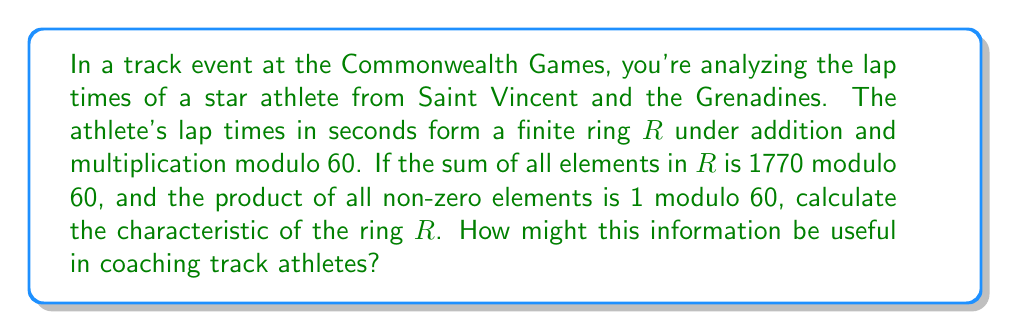Show me your answer to this math problem. Let's approach this step-by-step:

1) In a finite ring, the characteristic is the smallest positive integer $n$ such that $n \cdot a = 0$ for all elements $a$ in the ring. In this case, we're working modulo 60, so the characteristic must be a divisor of 60.

2) The sum of all elements in $R$ is 1770 mod 60, which is equivalent to 30 mod 60. Let's call the number of elements in $R$ as $|R|$. Then:

   $\sum_{a \in R} a \equiv 30 \pmod{60}$

3) The product of all non-zero elements is 1 mod 60. This is a key piece of information, as it's only possible in a field. The only field structure possible modulo 60 is $\mathbb{Z}_5$, as 5 is the only prime factor of 60 that works here.

4) So, $R$ must be isomorphic to $\mathbb{Z}_5$, and $|R| = 5$.

5) Now, let's use the sum information:

   $\sum_{a \in R} a \equiv 0 + 1 + 2 + 3 + 4 \equiv 10 \equiv 30 \pmod{60}$

6) This confirms our deduction that $R$ is isomorphic to $\mathbb{Z}_5$.

7) The characteristic of $\mathbb{Z}_5$ is 5.

As a coach, this information could be useful in several ways:
- The characteristic 5 suggests the athlete's lap times fall into 5 distinct categories modulo 60, which could help in identifying patterns in performance.
- The field structure indicates a balanced distribution of lap times, which could be a sign of consistent performance.
- Understanding these mathematical patterns could aid in developing training strategies to optimize the athlete's performance and consistency.
Answer: The characteristic of the ring $R$ is 5. 